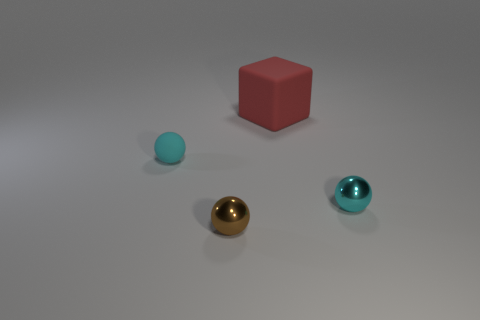Are there an equal number of large red matte objects on the right side of the red matte block and cyan metallic spheres?
Make the answer very short. No. Does the tiny cyan sphere to the left of the big red object have the same material as the big block that is to the right of the brown metallic object?
Ensure brevity in your answer.  Yes. The tiny cyan thing that is to the left of the cyan ball in front of the small cyan rubber sphere is what shape?
Ensure brevity in your answer.  Sphere. There is a thing that is made of the same material as the block; what color is it?
Provide a short and direct response. Cyan. Do the tiny rubber thing and the big block have the same color?
Your answer should be compact. No. The cyan rubber thing that is the same size as the brown ball is what shape?
Provide a short and direct response. Sphere. The red object has what size?
Offer a terse response. Large. There is a cyan thing right of the brown sphere; is its size the same as the rubber thing in front of the red matte block?
Your response must be concise. Yes. What is the color of the tiny sphere that is to the left of the tiny brown metallic object in front of the red block?
Your answer should be compact. Cyan. There is a brown thing that is the same size as the rubber sphere; what is its material?
Make the answer very short. Metal. 